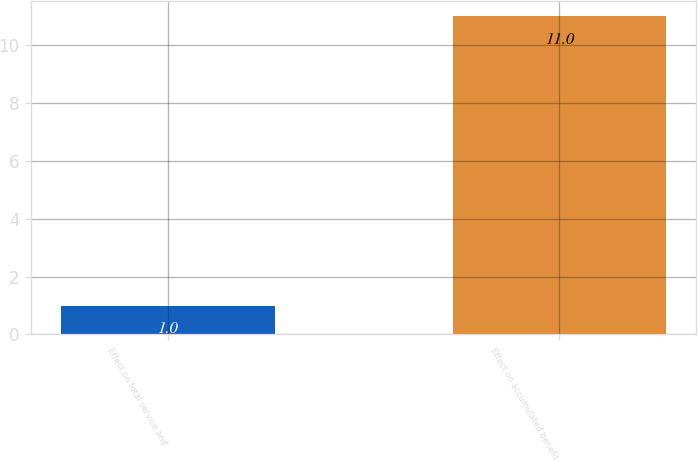Convert chart. <chart><loc_0><loc_0><loc_500><loc_500><bar_chart><fcel>Effect on total service and<fcel>Effect on accumulated benefit<nl><fcel>1<fcel>11<nl></chart> 